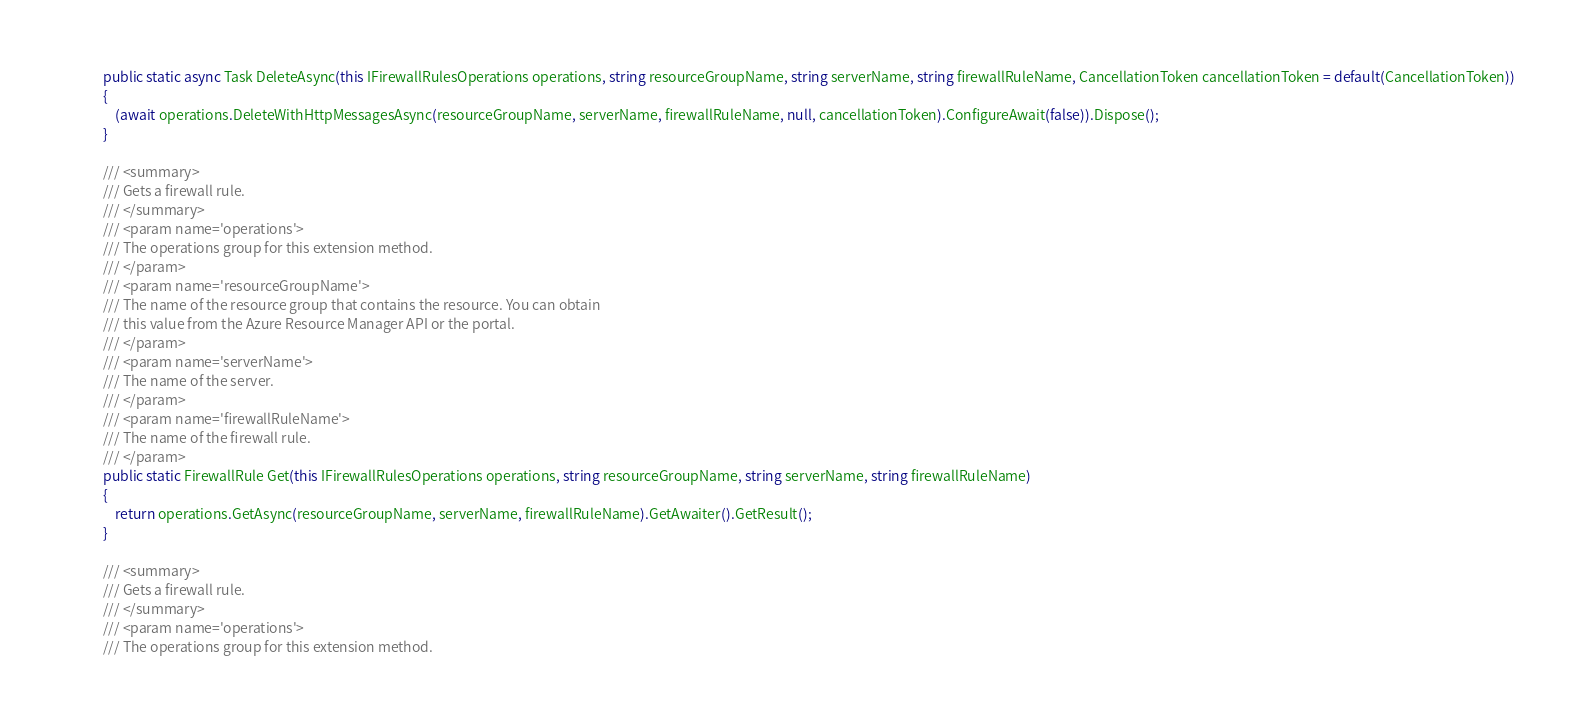<code> <loc_0><loc_0><loc_500><loc_500><_C#_>            public static async Task DeleteAsync(this IFirewallRulesOperations operations, string resourceGroupName, string serverName, string firewallRuleName, CancellationToken cancellationToken = default(CancellationToken))
            {
                (await operations.DeleteWithHttpMessagesAsync(resourceGroupName, serverName, firewallRuleName, null, cancellationToken).ConfigureAwait(false)).Dispose();
            }

            /// <summary>
            /// Gets a firewall rule.
            /// </summary>
            /// <param name='operations'>
            /// The operations group for this extension method.
            /// </param>
            /// <param name='resourceGroupName'>
            /// The name of the resource group that contains the resource. You can obtain
            /// this value from the Azure Resource Manager API or the portal.
            /// </param>
            /// <param name='serverName'>
            /// The name of the server.
            /// </param>
            /// <param name='firewallRuleName'>
            /// The name of the firewall rule.
            /// </param>
            public static FirewallRule Get(this IFirewallRulesOperations operations, string resourceGroupName, string serverName, string firewallRuleName)
            {
                return operations.GetAsync(resourceGroupName, serverName, firewallRuleName).GetAwaiter().GetResult();
            }

            /// <summary>
            /// Gets a firewall rule.
            /// </summary>
            /// <param name='operations'>
            /// The operations group for this extension method.</code> 